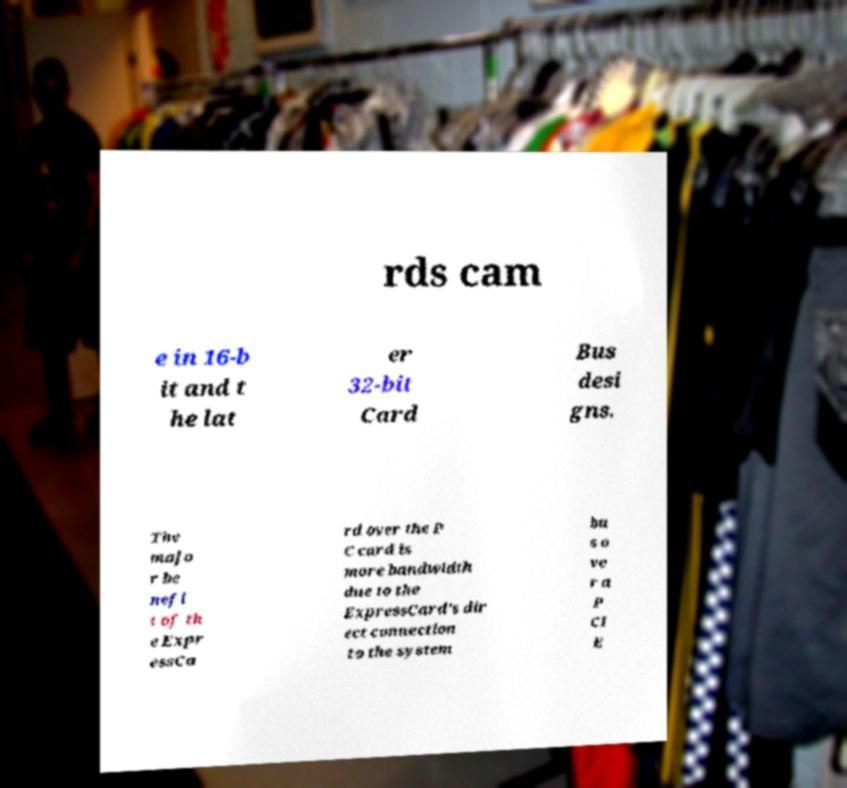I need the written content from this picture converted into text. Can you do that? rds cam e in 16-b it and t he lat er 32-bit Card Bus desi gns. The majo r be nefi t of th e Expr essCa rd over the P C card is more bandwidth due to the ExpressCard's dir ect connection to the system bu s o ve r a P CI E 